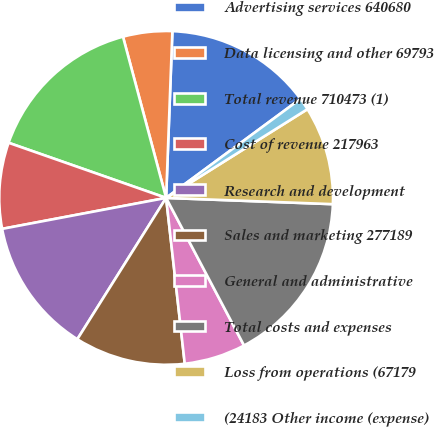Convert chart. <chart><loc_0><loc_0><loc_500><loc_500><pie_chart><fcel>Advertising services 640680<fcel>Data licensing and other 69793<fcel>Total revenue 710473 (1)<fcel>Cost of revenue 217963<fcel>Research and development<fcel>Sales and marketing 277189<fcel>General and administrative<fcel>Total costs and expenses<fcel>Loss from operations (67179<fcel>(24183 Other income (expense)<nl><fcel>14.29%<fcel>4.76%<fcel>15.48%<fcel>8.33%<fcel>13.1%<fcel>10.71%<fcel>5.95%<fcel>16.67%<fcel>9.52%<fcel>1.19%<nl></chart> 